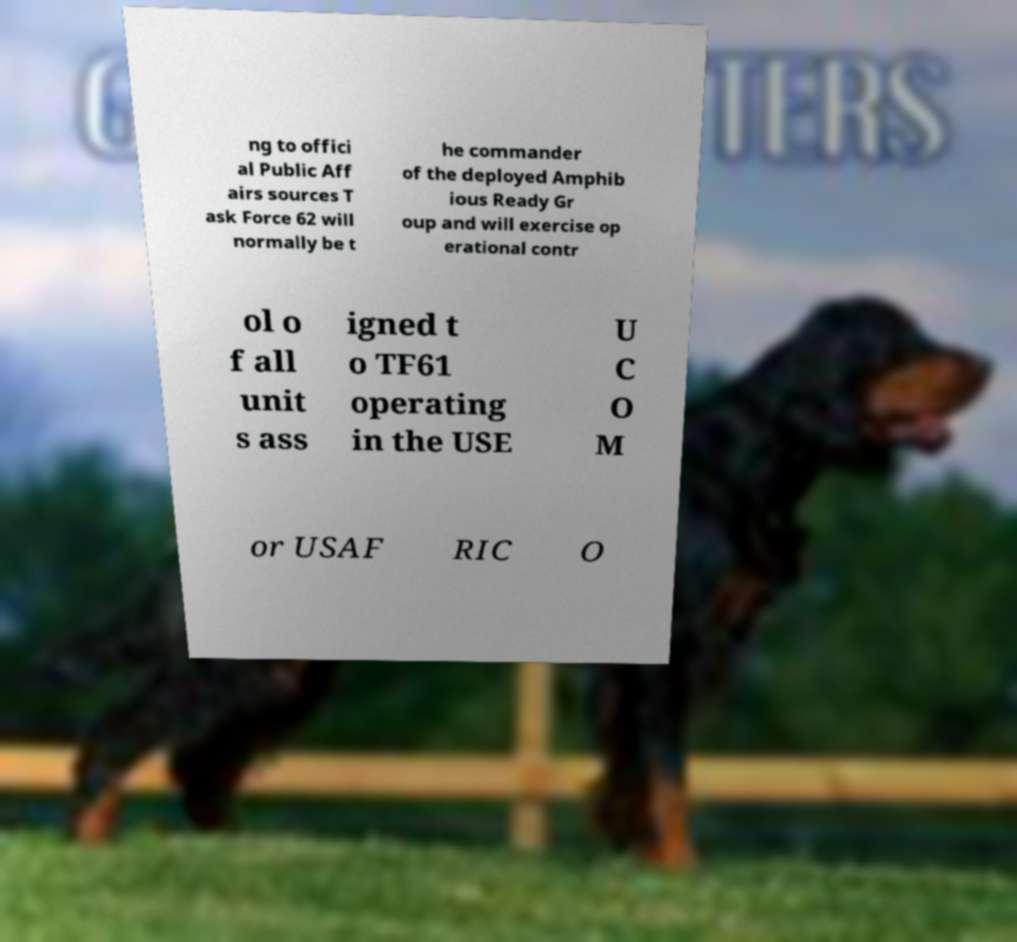What messages or text are displayed in this image? I need them in a readable, typed format. ng to offici al Public Aff airs sources T ask Force 62 will normally be t he commander of the deployed Amphib ious Ready Gr oup and will exercise op erational contr ol o f all unit s ass igned t o TF61 operating in the USE U C O M or USAF RIC O 